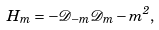Convert formula to latex. <formula><loc_0><loc_0><loc_500><loc_500>H _ { m } = - \mathcal { D } _ { - m } \mathcal { D } _ { m } - m ^ { 2 } ,</formula> 